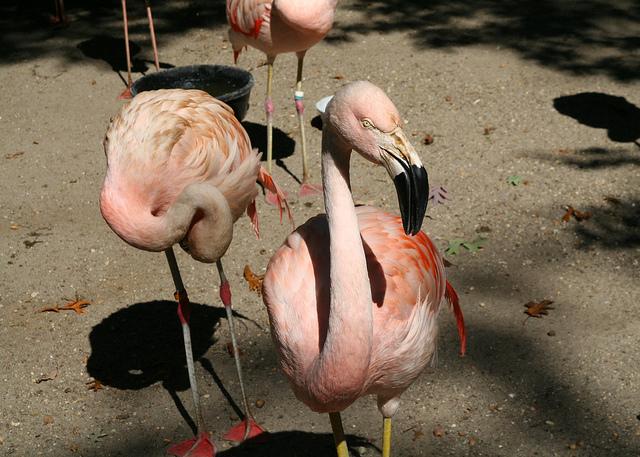Are there shadows on the ground?
Write a very short answer. Yes. What kind of animal is this?
Short answer required. Flamingo. How many flamingos are here?
Write a very short answer. 3. 